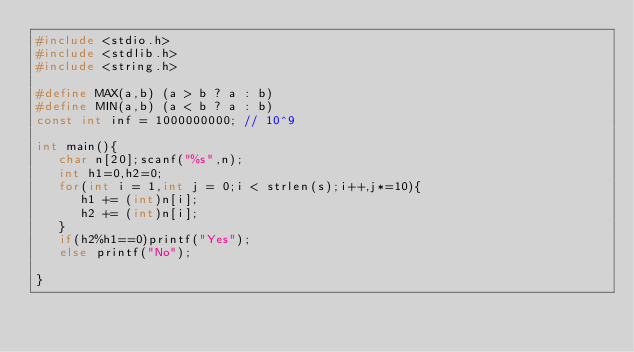Convert code to text. <code><loc_0><loc_0><loc_500><loc_500><_C_>#include <stdio.h>
#include <stdlib.h>
#include <string.h>

#define MAX(a,b) (a > b ? a : b)
#define MIN(a,b) (a < b ? a : b)
const int inf = 1000000000; // 10^9

int main(){
   char n[20];scanf("%s",n);
   int h1=0,h2=0;
   for(int i = 1,int j = 0;i < strlen(s);i++,j*=10){
      h1 += (int)n[i];
      h2 += (int)n[i];
   }
   if(h2%h1==0)printf("Yes");
   else printf("No");

}</code> 